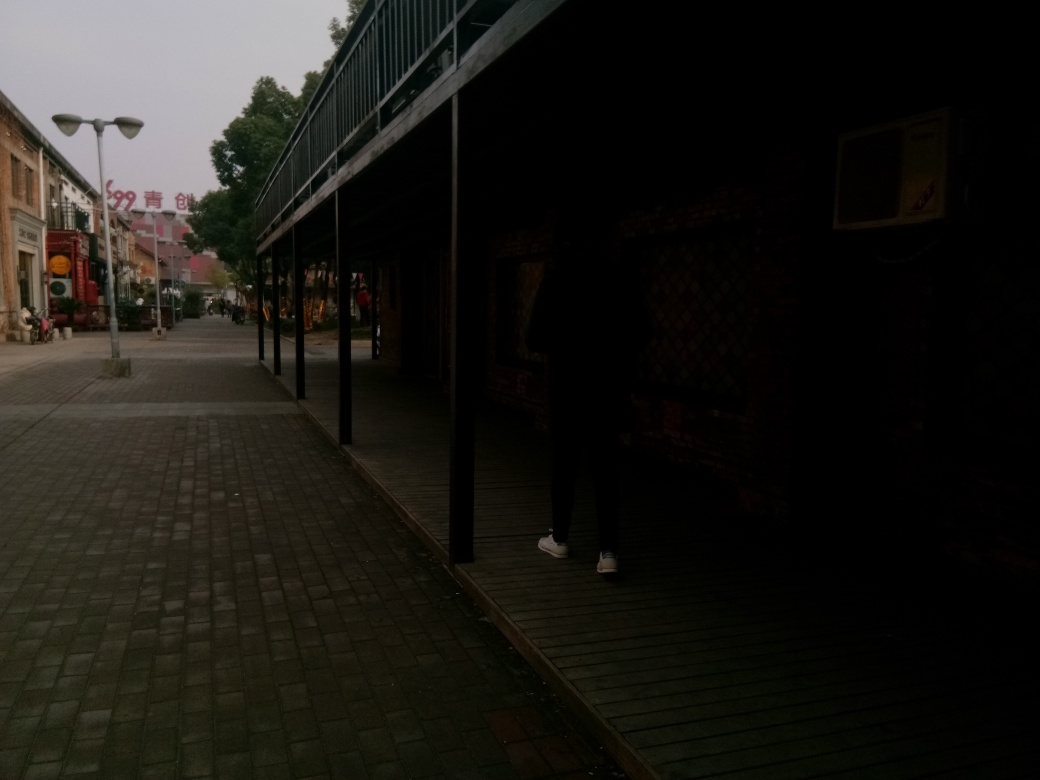How does the lighting in this image affect the mood of the scene? The subdued lighting creates a tranquil atmosphere, likely signaling evening or early morning. The lack of harsh shadows and the gentle illumination of the street and buildings contribute to a quiet and serene setting. What can be inferred about the location based on the architecture and signage? The architecture, with its traditional façade and signage featuring non-Latin characters, suggests that this scene could be situated in a town or city with cultural ties to East Asia. 